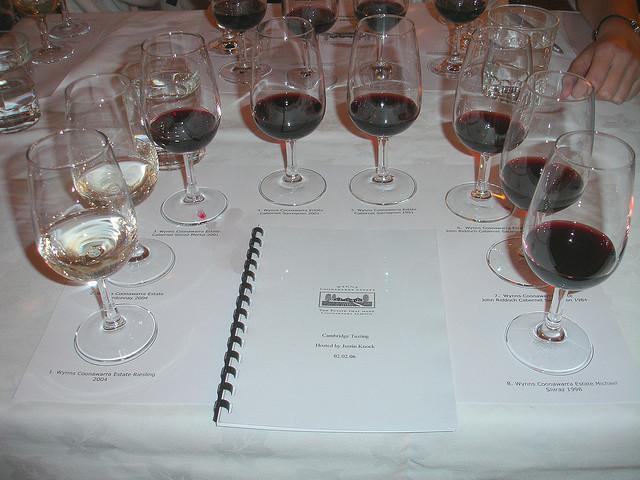How many glasses have red wine?
Give a very brief answer. 10. How many wine glasses are there?
Give a very brief answer. 9. How many cups are there?
Give a very brief answer. 2. 